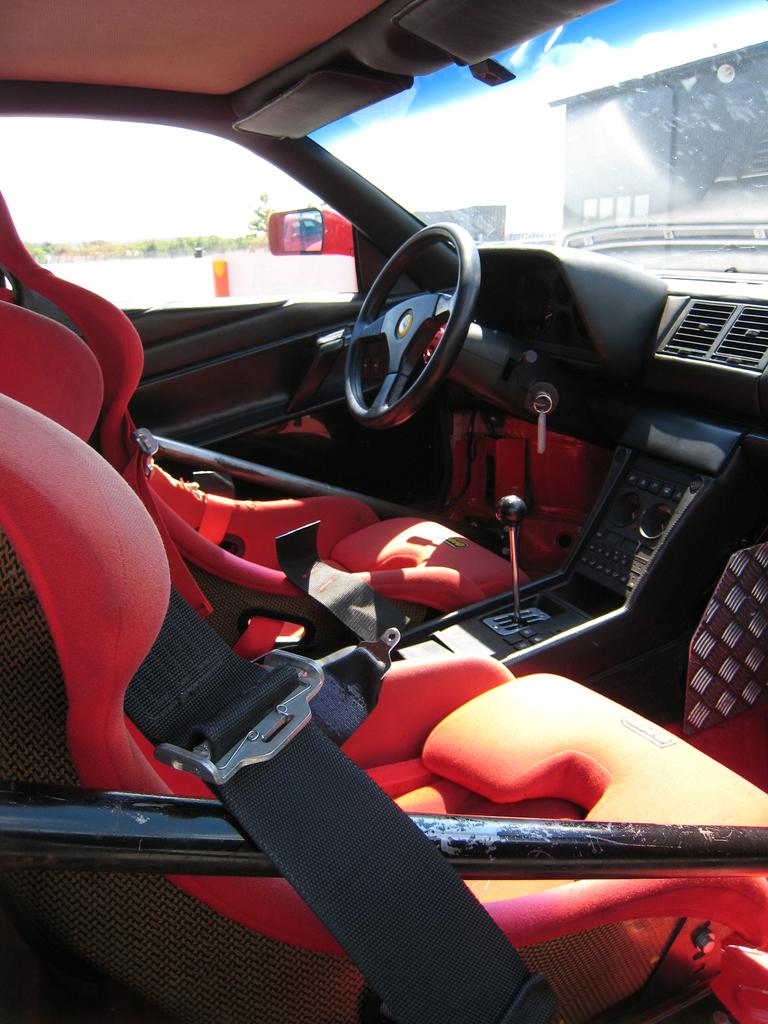What type of space is depicted in the image? The image shows the interior of a vehicle. What is a key component of the vehicle's interior? There is a steering wheel in the vehicle. What is located in front of the driver's seat? There is a dashboard in the vehicle. How many seats are visible in the image? There are seats in the vehicle. What can be seen outside the vehicle through the glass? Trees and buildings are visible through the vehicle's glass. How does the driver express their hate towards the cabbage in the image? There is no cabbage present in the image. 